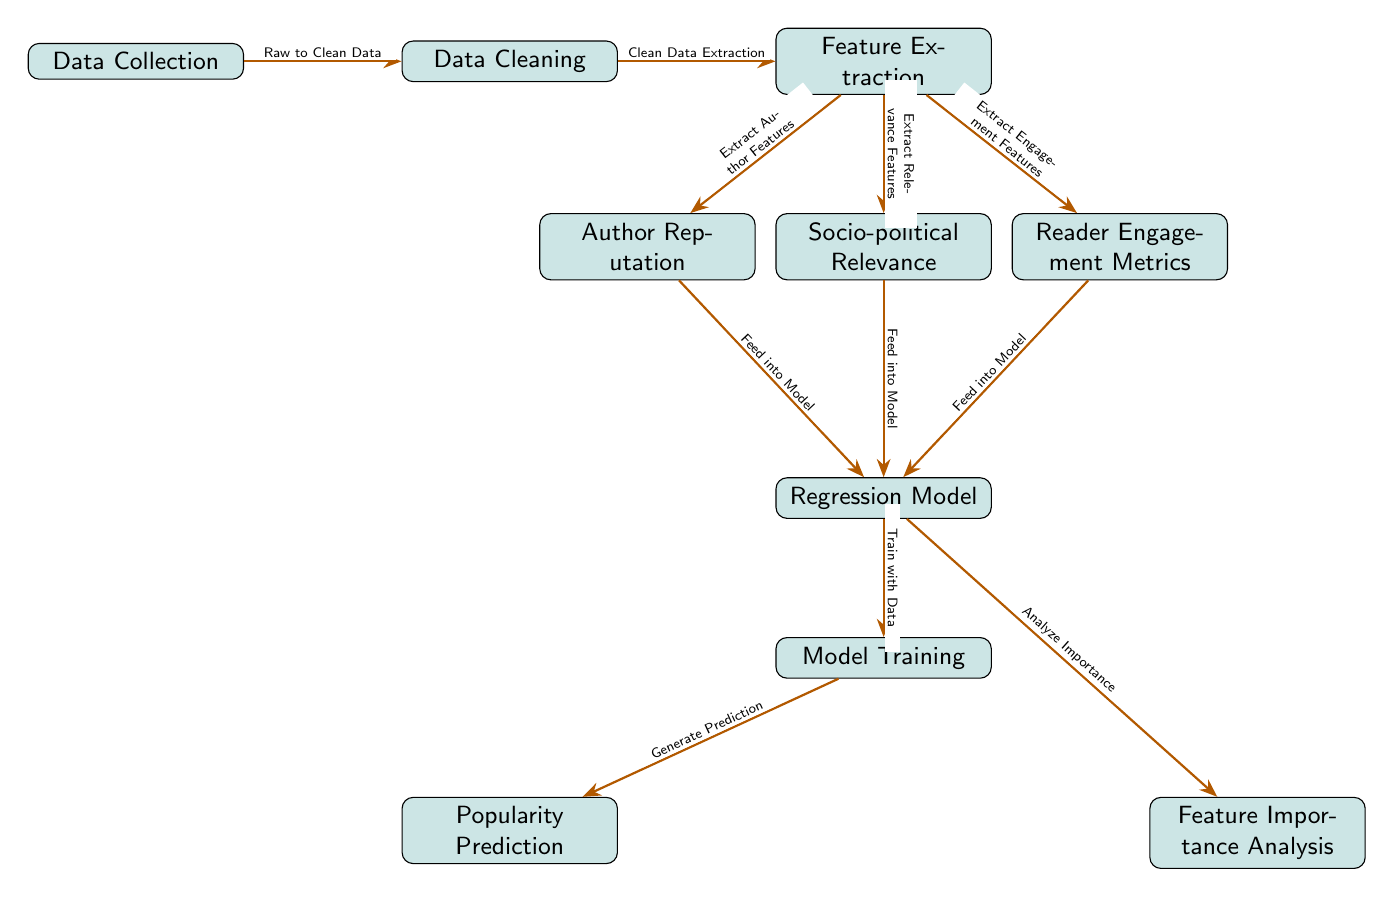What is the first step in the process? The first step is the "Data Collection" node, which collects the raw data necessary for further analysis.
Answer: Data Collection How many feature extraction categories are there? There are three categories for feature extraction based on the diagram: "Author Reputation," "Socio-political Relevance," and "Reader Engagement Metrics."
Answer: Three Which node feeds into the regression model related to reader engagement? The "Reader Engagement Metrics" node feeds into the regression model, indicating that information about reader engagement is utilized in the modeling process.
Answer: Reader Engagement Metrics What does the regression model analyze? The regression model analyzes the importance of the features that have been extracted and fed into it to understand their effect on the prediction of manuscript popularity.
Answer: Feature Importance What is the output of the model training process? The output of the model training process is the "Popularity Prediction," which indicates the final predicted popularity of a new political fiction manuscript based on the trained model.
Answer: Popularity Prediction What is the relationship between the model training and popularity prediction? The model training node generates predictions using the trained regression model, which demonstrates a direct functional relationship where trained data is applied to make predictions.
Answer: Generate Prediction How many edges connect to the regression model? There are three edges connecting to the regression model, each representing the input from the three feature extraction categories; thus, the regression model integrates multiple inputs.
Answer: Three What analysis is conducted after the regression model? After the regression model, the "Feature Importance Analysis" is conducted, which assesses how important each feature was in predicting popularity.
Answer: Feature Importance Analysis 